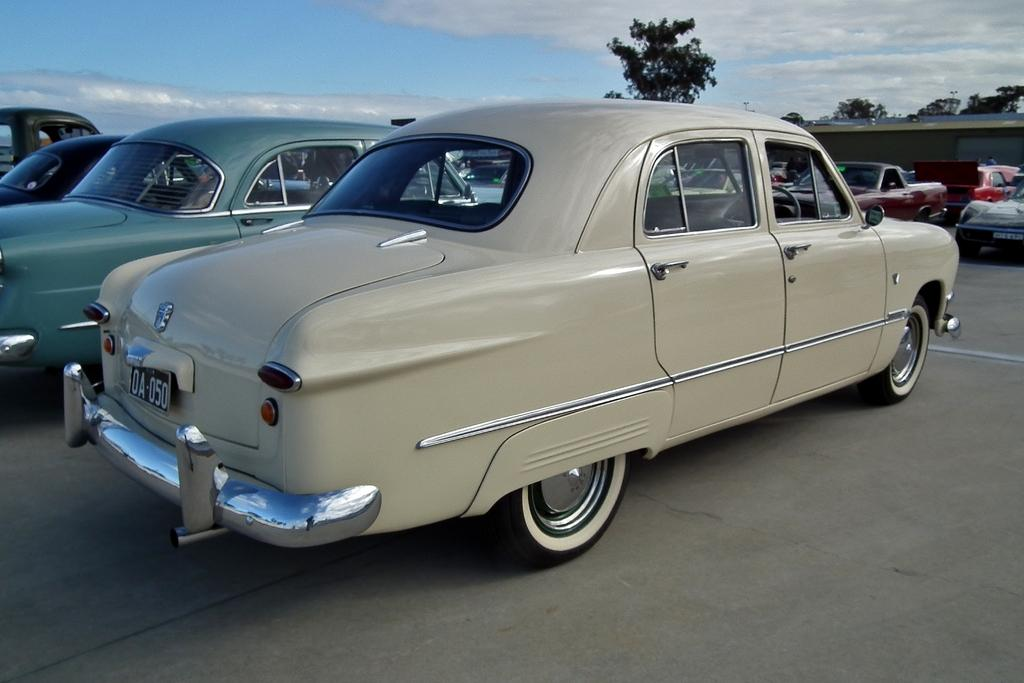What is the main subject of the image? The main subject of the image is a group of vehicles. How are the vehicles situated in the image? The vehicles are parked on the ground. What can be seen in the background of the image? There is a building and a group of trees in the background of the image. What is the condition of the sky in the image? The sky is visible in the background of the image, and it appears to be cloudy. Can you tell me how many people are smiling in the image? There are no people present in the image, so it is not possible to determine how many are smiling. What type of dust can be seen on the vehicles in the image? There is no dust visible on the vehicles in the image. 